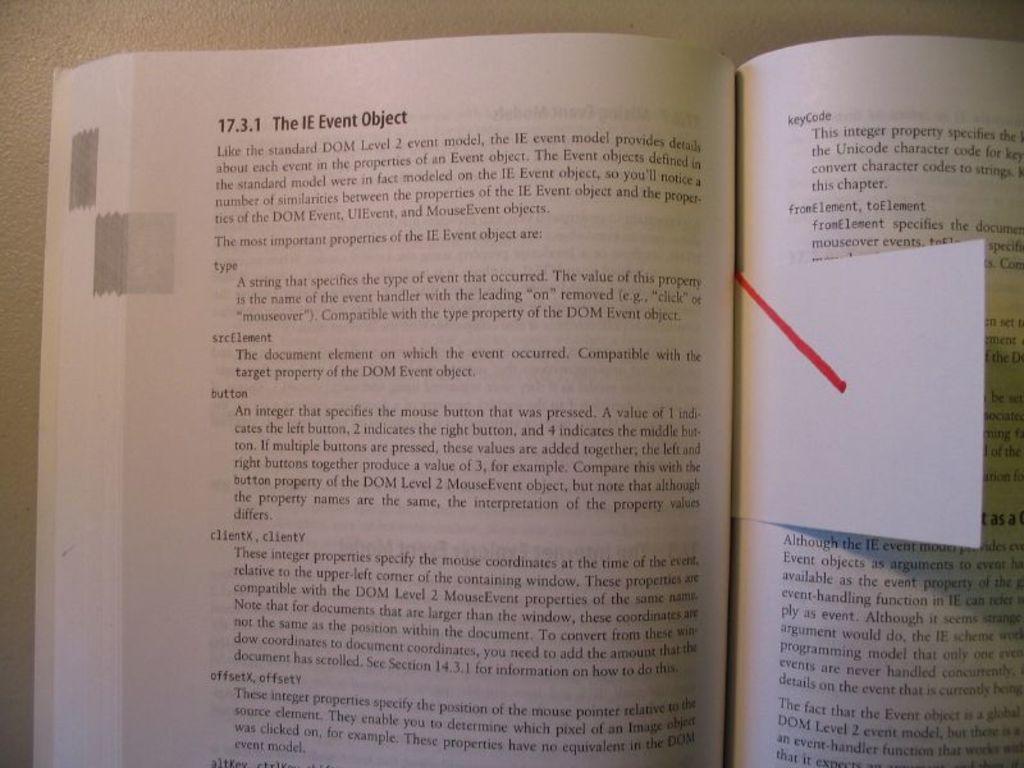What is title of this chapter?
Keep it short and to the point. The ie event object. 